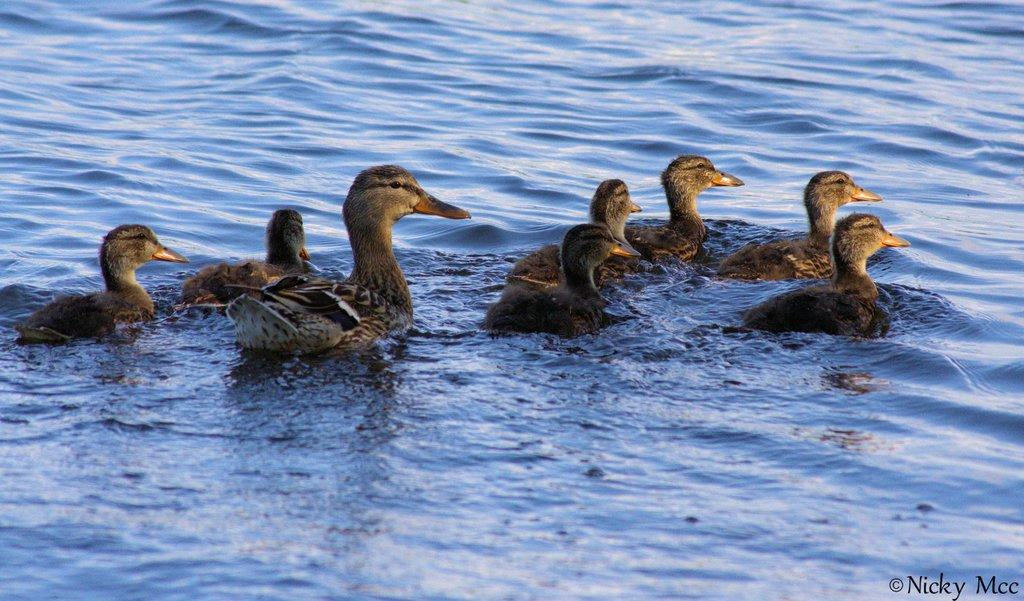What is visible in the image? There is water visible in the image. Are there any animals present in the image? Yes, there are ducks above the water in the image. How many ants can be seen causing trouble for the ducks in the image? There are no ants present in the image, and the ducks do not appear to be in any trouble. 